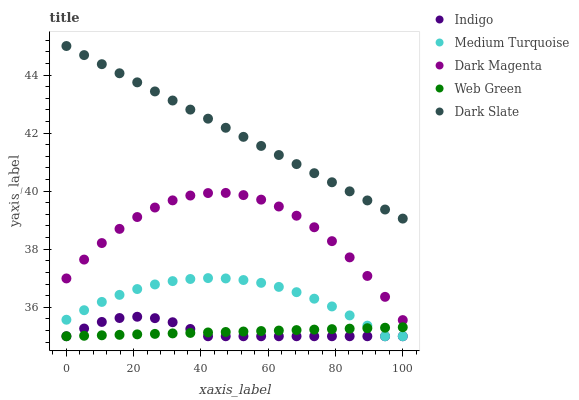Does Web Green have the minimum area under the curve?
Answer yes or no. Yes. Does Dark Slate have the maximum area under the curve?
Answer yes or no. Yes. Does Indigo have the minimum area under the curve?
Answer yes or no. No. Does Indigo have the maximum area under the curve?
Answer yes or no. No. Is Web Green the smoothest?
Answer yes or no. Yes. Is Dark Magenta the roughest?
Answer yes or no. Yes. Is Indigo the smoothest?
Answer yes or no. No. Is Indigo the roughest?
Answer yes or no. No. Does Web Green have the lowest value?
Answer yes or no. Yes. Does Dark Magenta have the lowest value?
Answer yes or no. No. Does Dark Slate have the highest value?
Answer yes or no. Yes. Does Indigo have the highest value?
Answer yes or no. No. Is Indigo less than Dark Slate?
Answer yes or no. Yes. Is Dark Slate greater than Dark Magenta?
Answer yes or no. Yes. Does Web Green intersect Indigo?
Answer yes or no. Yes. Is Web Green less than Indigo?
Answer yes or no. No. Is Web Green greater than Indigo?
Answer yes or no. No. Does Indigo intersect Dark Slate?
Answer yes or no. No. 